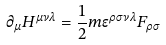Convert formula to latex. <formula><loc_0><loc_0><loc_500><loc_500>\partial _ { \mu } H ^ { \mu \nu \lambda } = \frac { 1 } { 2 } m \epsilon ^ { \rho \sigma \nu \lambda } F _ { \rho \sigma }</formula> 